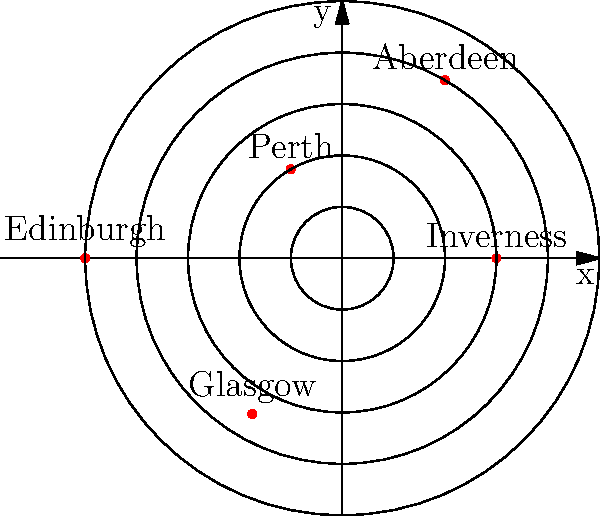In the polar coordinate system shown, five major Jacobite strongholds are represented. Which stronghold is located at coordinates $(r, \theta) = (4, \frac{\pi}{3})$, and what does this suggest about its strategic importance in the Jacobite rebellion? To answer this question, we need to follow these steps:

1. Understand the polar coordinate system:
   - $r$ represents the distance from the origin
   - $\theta$ represents the angle from the positive x-axis

2. Identify the point with coordinates $(r, \theta) = (4, \frac{\pi}{3})$:
   - $r = 4$ means it's on the fourth concentric circle from the center
   - $\theta = \frac{\pi}{3}$ is equivalent to 60 degrees counterclockwise from the positive x-axis

3. Locate the point on the diagram that matches these coordinates:
   - The point at $(4, \frac{\pi}{3})$ corresponds to Aberdeen

4. Interpret the strategic importance:
   - Aberdeen's position at $r = 4$ indicates it was relatively far from the central point of the rebellion
   - This suggests it was an important outpost or supply point for the Jacobites
   - Its coastal location (implied by historical knowledge) made it valuable for potential support or supplies from overseas

5. Historical context:
   - Aberdeen was indeed a significant Jacobite stronghold during the rebellion
   - Its port facilities and proximity to Jacobite-sympathetic regions made it strategically important

Therefore, Aberdeen's location in this polar coordinate system reflects its role as a crucial, outlying stronghold in the Jacobite rebellion, likely serving as a key point for supplies and potential foreign support.
Answer: Aberdeen; strategically important outlying stronghold and potential supply point 